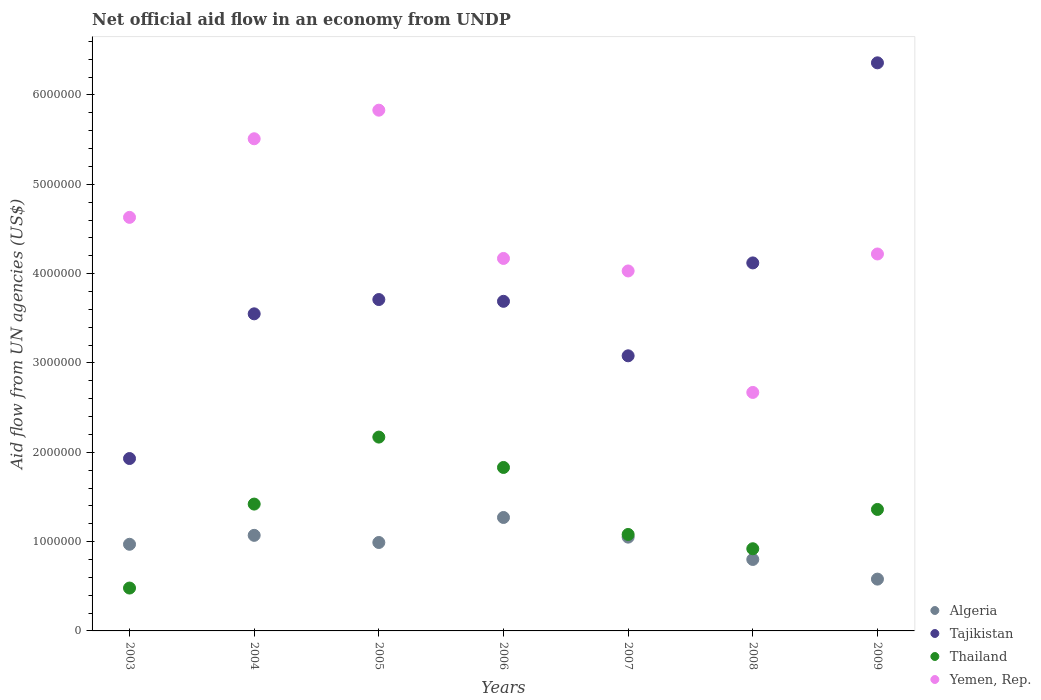What is the net official aid flow in Tajikistan in 2004?
Give a very brief answer. 3.55e+06. Across all years, what is the maximum net official aid flow in Tajikistan?
Provide a short and direct response. 6.36e+06. Across all years, what is the minimum net official aid flow in Thailand?
Make the answer very short. 4.80e+05. What is the total net official aid flow in Algeria in the graph?
Your answer should be very brief. 6.73e+06. What is the difference between the net official aid flow in Tajikistan in 2008 and that in 2009?
Make the answer very short. -2.24e+06. What is the difference between the net official aid flow in Thailand in 2005 and the net official aid flow in Yemen, Rep. in 2007?
Keep it short and to the point. -1.86e+06. What is the average net official aid flow in Thailand per year?
Offer a terse response. 1.32e+06. In the year 2007, what is the difference between the net official aid flow in Tajikistan and net official aid flow in Thailand?
Give a very brief answer. 2.00e+06. In how many years, is the net official aid flow in Yemen, Rep. greater than 5800000 US$?
Your answer should be very brief. 1. What is the ratio of the net official aid flow in Thailand in 2006 to that in 2009?
Provide a short and direct response. 1.35. Is the difference between the net official aid flow in Tajikistan in 2007 and 2008 greater than the difference between the net official aid flow in Thailand in 2007 and 2008?
Your response must be concise. No. What is the difference between the highest and the second highest net official aid flow in Algeria?
Your answer should be compact. 2.00e+05. What is the difference between the highest and the lowest net official aid flow in Thailand?
Offer a very short reply. 1.69e+06. In how many years, is the net official aid flow in Thailand greater than the average net official aid flow in Thailand taken over all years?
Your answer should be very brief. 4. Is the sum of the net official aid flow in Yemen, Rep. in 2003 and 2006 greater than the maximum net official aid flow in Algeria across all years?
Give a very brief answer. Yes. Is it the case that in every year, the sum of the net official aid flow in Tajikistan and net official aid flow in Thailand  is greater than the sum of net official aid flow in Yemen, Rep. and net official aid flow in Algeria?
Ensure brevity in your answer.  Yes. Is it the case that in every year, the sum of the net official aid flow in Thailand and net official aid flow in Yemen, Rep.  is greater than the net official aid flow in Tajikistan?
Give a very brief answer. No. Does the net official aid flow in Algeria monotonically increase over the years?
Your response must be concise. No. Is the net official aid flow in Algeria strictly less than the net official aid flow in Yemen, Rep. over the years?
Your answer should be very brief. Yes. How many years are there in the graph?
Your answer should be compact. 7. Does the graph contain any zero values?
Your response must be concise. No. Does the graph contain grids?
Provide a short and direct response. No. Where does the legend appear in the graph?
Keep it short and to the point. Bottom right. How many legend labels are there?
Your answer should be very brief. 4. What is the title of the graph?
Keep it short and to the point. Net official aid flow in an economy from UNDP. What is the label or title of the X-axis?
Your response must be concise. Years. What is the label or title of the Y-axis?
Give a very brief answer. Aid flow from UN agencies (US$). What is the Aid flow from UN agencies (US$) of Algeria in 2003?
Your response must be concise. 9.70e+05. What is the Aid flow from UN agencies (US$) of Tajikistan in 2003?
Make the answer very short. 1.93e+06. What is the Aid flow from UN agencies (US$) of Yemen, Rep. in 2003?
Your answer should be very brief. 4.63e+06. What is the Aid flow from UN agencies (US$) in Algeria in 2004?
Ensure brevity in your answer.  1.07e+06. What is the Aid flow from UN agencies (US$) in Tajikistan in 2004?
Offer a very short reply. 3.55e+06. What is the Aid flow from UN agencies (US$) in Thailand in 2004?
Your answer should be very brief. 1.42e+06. What is the Aid flow from UN agencies (US$) of Yemen, Rep. in 2004?
Your answer should be very brief. 5.51e+06. What is the Aid flow from UN agencies (US$) of Algeria in 2005?
Keep it short and to the point. 9.90e+05. What is the Aid flow from UN agencies (US$) in Tajikistan in 2005?
Offer a very short reply. 3.71e+06. What is the Aid flow from UN agencies (US$) in Thailand in 2005?
Your answer should be very brief. 2.17e+06. What is the Aid flow from UN agencies (US$) in Yemen, Rep. in 2005?
Your answer should be compact. 5.83e+06. What is the Aid flow from UN agencies (US$) in Algeria in 2006?
Your answer should be compact. 1.27e+06. What is the Aid flow from UN agencies (US$) of Tajikistan in 2006?
Keep it short and to the point. 3.69e+06. What is the Aid flow from UN agencies (US$) of Thailand in 2006?
Ensure brevity in your answer.  1.83e+06. What is the Aid flow from UN agencies (US$) of Yemen, Rep. in 2006?
Offer a very short reply. 4.17e+06. What is the Aid flow from UN agencies (US$) of Algeria in 2007?
Give a very brief answer. 1.05e+06. What is the Aid flow from UN agencies (US$) in Tajikistan in 2007?
Give a very brief answer. 3.08e+06. What is the Aid flow from UN agencies (US$) of Thailand in 2007?
Keep it short and to the point. 1.08e+06. What is the Aid flow from UN agencies (US$) of Yemen, Rep. in 2007?
Provide a succinct answer. 4.03e+06. What is the Aid flow from UN agencies (US$) in Tajikistan in 2008?
Keep it short and to the point. 4.12e+06. What is the Aid flow from UN agencies (US$) of Thailand in 2008?
Make the answer very short. 9.20e+05. What is the Aid flow from UN agencies (US$) in Yemen, Rep. in 2008?
Offer a terse response. 2.67e+06. What is the Aid flow from UN agencies (US$) in Algeria in 2009?
Ensure brevity in your answer.  5.80e+05. What is the Aid flow from UN agencies (US$) of Tajikistan in 2009?
Your answer should be compact. 6.36e+06. What is the Aid flow from UN agencies (US$) in Thailand in 2009?
Offer a very short reply. 1.36e+06. What is the Aid flow from UN agencies (US$) of Yemen, Rep. in 2009?
Ensure brevity in your answer.  4.22e+06. Across all years, what is the maximum Aid flow from UN agencies (US$) in Algeria?
Make the answer very short. 1.27e+06. Across all years, what is the maximum Aid flow from UN agencies (US$) in Tajikistan?
Your answer should be compact. 6.36e+06. Across all years, what is the maximum Aid flow from UN agencies (US$) in Thailand?
Make the answer very short. 2.17e+06. Across all years, what is the maximum Aid flow from UN agencies (US$) in Yemen, Rep.?
Ensure brevity in your answer.  5.83e+06. Across all years, what is the minimum Aid flow from UN agencies (US$) in Algeria?
Ensure brevity in your answer.  5.80e+05. Across all years, what is the minimum Aid flow from UN agencies (US$) of Tajikistan?
Offer a very short reply. 1.93e+06. Across all years, what is the minimum Aid flow from UN agencies (US$) in Yemen, Rep.?
Make the answer very short. 2.67e+06. What is the total Aid flow from UN agencies (US$) in Algeria in the graph?
Offer a very short reply. 6.73e+06. What is the total Aid flow from UN agencies (US$) in Tajikistan in the graph?
Make the answer very short. 2.64e+07. What is the total Aid flow from UN agencies (US$) of Thailand in the graph?
Your response must be concise. 9.26e+06. What is the total Aid flow from UN agencies (US$) of Yemen, Rep. in the graph?
Your response must be concise. 3.11e+07. What is the difference between the Aid flow from UN agencies (US$) of Tajikistan in 2003 and that in 2004?
Provide a succinct answer. -1.62e+06. What is the difference between the Aid flow from UN agencies (US$) in Thailand in 2003 and that in 2004?
Make the answer very short. -9.40e+05. What is the difference between the Aid flow from UN agencies (US$) in Yemen, Rep. in 2003 and that in 2004?
Your answer should be very brief. -8.80e+05. What is the difference between the Aid flow from UN agencies (US$) of Algeria in 2003 and that in 2005?
Keep it short and to the point. -2.00e+04. What is the difference between the Aid flow from UN agencies (US$) of Tajikistan in 2003 and that in 2005?
Keep it short and to the point. -1.78e+06. What is the difference between the Aid flow from UN agencies (US$) of Thailand in 2003 and that in 2005?
Give a very brief answer. -1.69e+06. What is the difference between the Aid flow from UN agencies (US$) in Yemen, Rep. in 2003 and that in 2005?
Provide a succinct answer. -1.20e+06. What is the difference between the Aid flow from UN agencies (US$) in Tajikistan in 2003 and that in 2006?
Your answer should be very brief. -1.76e+06. What is the difference between the Aid flow from UN agencies (US$) in Thailand in 2003 and that in 2006?
Provide a succinct answer. -1.35e+06. What is the difference between the Aid flow from UN agencies (US$) in Yemen, Rep. in 2003 and that in 2006?
Offer a terse response. 4.60e+05. What is the difference between the Aid flow from UN agencies (US$) in Algeria in 2003 and that in 2007?
Offer a very short reply. -8.00e+04. What is the difference between the Aid flow from UN agencies (US$) in Tajikistan in 2003 and that in 2007?
Offer a terse response. -1.15e+06. What is the difference between the Aid flow from UN agencies (US$) of Thailand in 2003 and that in 2007?
Give a very brief answer. -6.00e+05. What is the difference between the Aid flow from UN agencies (US$) in Tajikistan in 2003 and that in 2008?
Offer a very short reply. -2.19e+06. What is the difference between the Aid flow from UN agencies (US$) in Thailand in 2003 and that in 2008?
Give a very brief answer. -4.40e+05. What is the difference between the Aid flow from UN agencies (US$) in Yemen, Rep. in 2003 and that in 2008?
Your response must be concise. 1.96e+06. What is the difference between the Aid flow from UN agencies (US$) in Tajikistan in 2003 and that in 2009?
Ensure brevity in your answer.  -4.43e+06. What is the difference between the Aid flow from UN agencies (US$) of Thailand in 2003 and that in 2009?
Give a very brief answer. -8.80e+05. What is the difference between the Aid flow from UN agencies (US$) of Yemen, Rep. in 2003 and that in 2009?
Give a very brief answer. 4.10e+05. What is the difference between the Aid flow from UN agencies (US$) of Thailand in 2004 and that in 2005?
Provide a short and direct response. -7.50e+05. What is the difference between the Aid flow from UN agencies (US$) of Yemen, Rep. in 2004 and that in 2005?
Your response must be concise. -3.20e+05. What is the difference between the Aid flow from UN agencies (US$) of Algeria in 2004 and that in 2006?
Keep it short and to the point. -2.00e+05. What is the difference between the Aid flow from UN agencies (US$) of Thailand in 2004 and that in 2006?
Keep it short and to the point. -4.10e+05. What is the difference between the Aid flow from UN agencies (US$) in Yemen, Rep. in 2004 and that in 2006?
Your answer should be very brief. 1.34e+06. What is the difference between the Aid flow from UN agencies (US$) of Algeria in 2004 and that in 2007?
Keep it short and to the point. 2.00e+04. What is the difference between the Aid flow from UN agencies (US$) of Tajikistan in 2004 and that in 2007?
Your answer should be very brief. 4.70e+05. What is the difference between the Aid flow from UN agencies (US$) in Thailand in 2004 and that in 2007?
Offer a terse response. 3.40e+05. What is the difference between the Aid flow from UN agencies (US$) in Yemen, Rep. in 2004 and that in 2007?
Your answer should be compact. 1.48e+06. What is the difference between the Aid flow from UN agencies (US$) in Tajikistan in 2004 and that in 2008?
Your answer should be very brief. -5.70e+05. What is the difference between the Aid flow from UN agencies (US$) in Yemen, Rep. in 2004 and that in 2008?
Offer a very short reply. 2.84e+06. What is the difference between the Aid flow from UN agencies (US$) of Tajikistan in 2004 and that in 2009?
Your response must be concise. -2.81e+06. What is the difference between the Aid flow from UN agencies (US$) of Yemen, Rep. in 2004 and that in 2009?
Your response must be concise. 1.29e+06. What is the difference between the Aid flow from UN agencies (US$) of Algeria in 2005 and that in 2006?
Your answer should be very brief. -2.80e+05. What is the difference between the Aid flow from UN agencies (US$) in Thailand in 2005 and that in 2006?
Offer a very short reply. 3.40e+05. What is the difference between the Aid flow from UN agencies (US$) in Yemen, Rep. in 2005 and that in 2006?
Give a very brief answer. 1.66e+06. What is the difference between the Aid flow from UN agencies (US$) of Tajikistan in 2005 and that in 2007?
Make the answer very short. 6.30e+05. What is the difference between the Aid flow from UN agencies (US$) in Thailand in 2005 and that in 2007?
Your answer should be very brief. 1.09e+06. What is the difference between the Aid flow from UN agencies (US$) of Yemen, Rep. in 2005 and that in 2007?
Offer a very short reply. 1.80e+06. What is the difference between the Aid flow from UN agencies (US$) in Algeria in 2005 and that in 2008?
Offer a very short reply. 1.90e+05. What is the difference between the Aid flow from UN agencies (US$) in Tajikistan in 2005 and that in 2008?
Offer a very short reply. -4.10e+05. What is the difference between the Aid flow from UN agencies (US$) in Thailand in 2005 and that in 2008?
Give a very brief answer. 1.25e+06. What is the difference between the Aid flow from UN agencies (US$) in Yemen, Rep. in 2005 and that in 2008?
Offer a very short reply. 3.16e+06. What is the difference between the Aid flow from UN agencies (US$) of Algeria in 2005 and that in 2009?
Ensure brevity in your answer.  4.10e+05. What is the difference between the Aid flow from UN agencies (US$) in Tajikistan in 2005 and that in 2009?
Keep it short and to the point. -2.65e+06. What is the difference between the Aid flow from UN agencies (US$) in Thailand in 2005 and that in 2009?
Provide a succinct answer. 8.10e+05. What is the difference between the Aid flow from UN agencies (US$) in Yemen, Rep. in 2005 and that in 2009?
Your answer should be very brief. 1.61e+06. What is the difference between the Aid flow from UN agencies (US$) in Tajikistan in 2006 and that in 2007?
Give a very brief answer. 6.10e+05. What is the difference between the Aid flow from UN agencies (US$) of Thailand in 2006 and that in 2007?
Provide a succinct answer. 7.50e+05. What is the difference between the Aid flow from UN agencies (US$) in Yemen, Rep. in 2006 and that in 2007?
Provide a succinct answer. 1.40e+05. What is the difference between the Aid flow from UN agencies (US$) in Algeria in 2006 and that in 2008?
Offer a very short reply. 4.70e+05. What is the difference between the Aid flow from UN agencies (US$) in Tajikistan in 2006 and that in 2008?
Make the answer very short. -4.30e+05. What is the difference between the Aid flow from UN agencies (US$) of Thailand in 2006 and that in 2008?
Give a very brief answer. 9.10e+05. What is the difference between the Aid flow from UN agencies (US$) of Yemen, Rep. in 2006 and that in 2008?
Your response must be concise. 1.50e+06. What is the difference between the Aid flow from UN agencies (US$) in Algeria in 2006 and that in 2009?
Your response must be concise. 6.90e+05. What is the difference between the Aid flow from UN agencies (US$) in Tajikistan in 2006 and that in 2009?
Your answer should be compact. -2.67e+06. What is the difference between the Aid flow from UN agencies (US$) in Tajikistan in 2007 and that in 2008?
Keep it short and to the point. -1.04e+06. What is the difference between the Aid flow from UN agencies (US$) in Yemen, Rep. in 2007 and that in 2008?
Provide a succinct answer. 1.36e+06. What is the difference between the Aid flow from UN agencies (US$) of Tajikistan in 2007 and that in 2009?
Offer a very short reply. -3.28e+06. What is the difference between the Aid flow from UN agencies (US$) of Thailand in 2007 and that in 2009?
Your response must be concise. -2.80e+05. What is the difference between the Aid flow from UN agencies (US$) in Algeria in 2008 and that in 2009?
Ensure brevity in your answer.  2.20e+05. What is the difference between the Aid flow from UN agencies (US$) in Tajikistan in 2008 and that in 2009?
Provide a short and direct response. -2.24e+06. What is the difference between the Aid flow from UN agencies (US$) in Thailand in 2008 and that in 2009?
Provide a succinct answer. -4.40e+05. What is the difference between the Aid flow from UN agencies (US$) in Yemen, Rep. in 2008 and that in 2009?
Your answer should be very brief. -1.55e+06. What is the difference between the Aid flow from UN agencies (US$) of Algeria in 2003 and the Aid flow from UN agencies (US$) of Tajikistan in 2004?
Offer a terse response. -2.58e+06. What is the difference between the Aid flow from UN agencies (US$) in Algeria in 2003 and the Aid flow from UN agencies (US$) in Thailand in 2004?
Offer a very short reply. -4.50e+05. What is the difference between the Aid flow from UN agencies (US$) of Algeria in 2003 and the Aid flow from UN agencies (US$) of Yemen, Rep. in 2004?
Give a very brief answer. -4.54e+06. What is the difference between the Aid flow from UN agencies (US$) of Tajikistan in 2003 and the Aid flow from UN agencies (US$) of Thailand in 2004?
Your answer should be compact. 5.10e+05. What is the difference between the Aid flow from UN agencies (US$) in Tajikistan in 2003 and the Aid flow from UN agencies (US$) in Yemen, Rep. in 2004?
Keep it short and to the point. -3.58e+06. What is the difference between the Aid flow from UN agencies (US$) in Thailand in 2003 and the Aid flow from UN agencies (US$) in Yemen, Rep. in 2004?
Your answer should be very brief. -5.03e+06. What is the difference between the Aid flow from UN agencies (US$) of Algeria in 2003 and the Aid flow from UN agencies (US$) of Tajikistan in 2005?
Provide a short and direct response. -2.74e+06. What is the difference between the Aid flow from UN agencies (US$) of Algeria in 2003 and the Aid flow from UN agencies (US$) of Thailand in 2005?
Provide a succinct answer. -1.20e+06. What is the difference between the Aid flow from UN agencies (US$) of Algeria in 2003 and the Aid flow from UN agencies (US$) of Yemen, Rep. in 2005?
Offer a very short reply. -4.86e+06. What is the difference between the Aid flow from UN agencies (US$) of Tajikistan in 2003 and the Aid flow from UN agencies (US$) of Thailand in 2005?
Your answer should be compact. -2.40e+05. What is the difference between the Aid flow from UN agencies (US$) in Tajikistan in 2003 and the Aid flow from UN agencies (US$) in Yemen, Rep. in 2005?
Provide a succinct answer. -3.90e+06. What is the difference between the Aid flow from UN agencies (US$) in Thailand in 2003 and the Aid flow from UN agencies (US$) in Yemen, Rep. in 2005?
Your answer should be very brief. -5.35e+06. What is the difference between the Aid flow from UN agencies (US$) of Algeria in 2003 and the Aid flow from UN agencies (US$) of Tajikistan in 2006?
Offer a very short reply. -2.72e+06. What is the difference between the Aid flow from UN agencies (US$) of Algeria in 2003 and the Aid flow from UN agencies (US$) of Thailand in 2006?
Ensure brevity in your answer.  -8.60e+05. What is the difference between the Aid flow from UN agencies (US$) of Algeria in 2003 and the Aid flow from UN agencies (US$) of Yemen, Rep. in 2006?
Make the answer very short. -3.20e+06. What is the difference between the Aid flow from UN agencies (US$) in Tajikistan in 2003 and the Aid flow from UN agencies (US$) in Yemen, Rep. in 2006?
Your answer should be compact. -2.24e+06. What is the difference between the Aid flow from UN agencies (US$) of Thailand in 2003 and the Aid flow from UN agencies (US$) of Yemen, Rep. in 2006?
Make the answer very short. -3.69e+06. What is the difference between the Aid flow from UN agencies (US$) of Algeria in 2003 and the Aid flow from UN agencies (US$) of Tajikistan in 2007?
Provide a short and direct response. -2.11e+06. What is the difference between the Aid flow from UN agencies (US$) of Algeria in 2003 and the Aid flow from UN agencies (US$) of Yemen, Rep. in 2007?
Offer a terse response. -3.06e+06. What is the difference between the Aid flow from UN agencies (US$) in Tajikistan in 2003 and the Aid flow from UN agencies (US$) in Thailand in 2007?
Your answer should be compact. 8.50e+05. What is the difference between the Aid flow from UN agencies (US$) in Tajikistan in 2003 and the Aid flow from UN agencies (US$) in Yemen, Rep. in 2007?
Your answer should be compact. -2.10e+06. What is the difference between the Aid flow from UN agencies (US$) in Thailand in 2003 and the Aid flow from UN agencies (US$) in Yemen, Rep. in 2007?
Offer a very short reply. -3.55e+06. What is the difference between the Aid flow from UN agencies (US$) of Algeria in 2003 and the Aid flow from UN agencies (US$) of Tajikistan in 2008?
Your answer should be very brief. -3.15e+06. What is the difference between the Aid flow from UN agencies (US$) of Algeria in 2003 and the Aid flow from UN agencies (US$) of Thailand in 2008?
Provide a succinct answer. 5.00e+04. What is the difference between the Aid flow from UN agencies (US$) of Algeria in 2003 and the Aid flow from UN agencies (US$) of Yemen, Rep. in 2008?
Provide a succinct answer. -1.70e+06. What is the difference between the Aid flow from UN agencies (US$) in Tajikistan in 2003 and the Aid flow from UN agencies (US$) in Thailand in 2008?
Your response must be concise. 1.01e+06. What is the difference between the Aid flow from UN agencies (US$) in Tajikistan in 2003 and the Aid flow from UN agencies (US$) in Yemen, Rep. in 2008?
Offer a very short reply. -7.40e+05. What is the difference between the Aid flow from UN agencies (US$) in Thailand in 2003 and the Aid flow from UN agencies (US$) in Yemen, Rep. in 2008?
Offer a terse response. -2.19e+06. What is the difference between the Aid flow from UN agencies (US$) in Algeria in 2003 and the Aid flow from UN agencies (US$) in Tajikistan in 2009?
Keep it short and to the point. -5.39e+06. What is the difference between the Aid flow from UN agencies (US$) of Algeria in 2003 and the Aid flow from UN agencies (US$) of Thailand in 2009?
Ensure brevity in your answer.  -3.90e+05. What is the difference between the Aid flow from UN agencies (US$) of Algeria in 2003 and the Aid flow from UN agencies (US$) of Yemen, Rep. in 2009?
Provide a succinct answer. -3.25e+06. What is the difference between the Aid flow from UN agencies (US$) in Tajikistan in 2003 and the Aid flow from UN agencies (US$) in Thailand in 2009?
Ensure brevity in your answer.  5.70e+05. What is the difference between the Aid flow from UN agencies (US$) of Tajikistan in 2003 and the Aid flow from UN agencies (US$) of Yemen, Rep. in 2009?
Offer a terse response. -2.29e+06. What is the difference between the Aid flow from UN agencies (US$) of Thailand in 2003 and the Aid flow from UN agencies (US$) of Yemen, Rep. in 2009?
Give a very brief answer. -3.74e+06. What is the difference between the Aid flow from UN agencies (US$) of Algeria in 2004 and the Aid flow from UN agencies (US$) of Tajikistan in 2005?
Your answer should be compact. -2.64e+06. What is the difference between the Aid flow from UN agencies (US$) in Algeria in 2004 and the Aid flow from UN agencies (US$) in Thailand in 2005?
Make the answer very short. -1.10e+06. What is the difference between the Aid flow from UN agencies (US$) in Algeria in 2004 and the Aid flow from UN agencies (US$) in Yemen, Rep. in 2005?
Keep it short and to the point. -4.76e+06. What is the difference between the Aid flow from UN agencies (US$) of Tajikistan in 2004 and the Aid flow from UN agencies (US$) of Thailand in 2005?
Your answer should be very brief. 1.38e+06. What is the difference between the Aid flow from UN agencies (US$) of Tajikistan in 2004 and the Aid flow from UN agencies (US$) of Yemen, Rep. in 2005?
Offer a very short reply. -2.28e+06. What is the difference between the Aid flow from UN agencies (US$) of Thailand in 2004 and the Aid flow from UN agencies (US$) of Yemen, Rep. in 2005?
Your answer should be compact. -4.41e+06. What is the difference between the Aid flow from UN agencies (US$) of Algeria in 2004 and the Aid flow from UN agencies (US$) of Tajikistan in 2006?
Your answer should be compact. -2.62e+06. What is the difference between the Aid flow from UN agencies (US$) in Algeria in 2004 and the Aid flow from UN agencies (US$) in Thailand in 2006?
Provide a succinct answer. -7.60e+05. What is the difference between the Aid flow from UN agencies (US$) of Algeria in 2004 and the Aid flow from UN agencies (US$) of Yemen, Rep. in 2006?
Give a very brief answer. -3.10e+06. What is the difference between the Aid flow from UN agencies (US$) in Tajikistan in 2004 and the Aid flow from UN agencies (US$) in Thailand in 2006?
Your answer should be very brief. 1.72e+06. What is the difference between the Aid flow from UN agencies (US$) of Tajikistan in 2004 and the Aid flow from UN agencies (US$) of Yemen, Rep. in 2006?
Offer a very short reply. -6.20e+05. What is the difference between the Aid flow from UN agencies (US$) of Thailand in 2004 and the Aid flow from UN agencies (US$) of Yemen, Rep. in 2006?
Your answer should be very brief. -2.75e+06. What is the difference between the Aid flow from UN agencies (US$) of Algeria in 2004 and the Aid flow from UN agencies (US$) of Tajikistan in 2007?
Offer a terse response. -2.01e+06. What is the difference between the Aid flow from UN agencies (US$) in Algeria in 2004 and the Aid flow from UN agencies (US$) in Yemen, Rep. in 2007?
Offer a very short reply. -2.96e+06. What is the difference between the Aid flow from UN agencies (US$) of Tajikistan in 2004 and the Aid flow from UN agencies (US$) of Thailand in 2007?
Ensure brevity in your answer.  2.47e+06. What is the difference between the Aid flow from UN agencies (US$) in Tajikistan in 2004 and the Aid flow from UN agencies (US$) in Yemen, Rep. in 2007?
Offer a terse response. -4.80e+05. What is the difference between the Aid flow from UN agencies (US$) in Thailand in 2004 and the Aid flow from UN agencies (US$) in Yemen, Rep. in 2007?
Ensure brevity in your answer.  -2.61e+06. What is the difference between the Aid flow from UN agencies (US$) of Algeria in 2004 and the Aid flow from UN agencies (US$) of Tajikistan in 2008?
Make the answer very short. -3.05e+06. What is the difference between the Aid flow from UN agencies (US$) in Algeria in 2004 and the Aid flow from UN agencies (US$) in Thailand in 2008?
Keep it short and to the point. 1.50e+05. What is the difference between the Aid flow from UN agencies (US$) in Algeria in 2004 and the Aid flow from UN agencies (US$) in Yemen, Rep. in 2008?
Your response must be concise. -1.60e+06. What is the difference between the Aid flow from UN agencies (US$) in Tajikistan in 2004 and the Aid flow from UN agencies (US$) in Thailand in 2008?
Make the answer very short. 2.63e+06. What is the difference between the Aid flow from UN agencies (US$) of Tajikistan in 2004 and the Aid flow from UN agencies (US$) of Yemen, Rep. in 2008?
Give a very brief answer. 8.80e+05. What is the difference between the Aid flow from UN agencies (US$) in Thailand in 2004 and the Aid flow from UN agencies (US$) in Yemen, Rep. in 2008?
Offer a very short reply. -1.25e+06. What is the difference between the Aid flow from UN agencies (US$) of Algeria in 2004 and the Aid flow from UN agencies (US$) of Tajikistan in 2009?
Keep it short and to the point. -5.29e+06. What is the difference between the Aid flow from UN agencies (US$) in Algeria in 2004 and the Aid flow from UN agencies (US$) in Yemen, Rep. in 2009?
Ensure brevity in your answer.  -3.15e+06. What is the difference between the Aid flow from UN agencies (US$) of Tajikistan in 2004 and the Aid flow from UN agencies (US$) of Thailand in 2009?
Offer a terse response. 2.19e+06. What is the difference between the Aid flow from UN agencies (US$) in Tajikistan in 2004 and the Aid flow from UN agencies (US$) in Yemen, Rep. in 2009?
Give a very brief answer. -6.70e+05. What is the difference between the Aid flow from UN agencies (US$) in Thailand in 2004 and the Aid flow from UN agencies (US$) in Yemen, Rep. in 2009?
Offer a terse response. -2.80e+06. What is the difference between the Aid flow from UN agencies (US$) of Algeria in 2005 and the Aid flow from UN agencies (US$) of Tajikistan in 2006?
Offer a very short reply. -2.70e+06. What is the difference between the Aid flow from UN agencies (US$) in Algeria in 2005 and the Aid flow from UN agencies (US$) in Thailand in 2006?
Ensure brevity in your answer.  -8.40e+05. What is the difference between the Aid flow from UN agencies (US$) in Algeria in 2005 and the Aid flow from UN agencies (US$) in Yemen, Rep. in 2006?
Your answer should be compact. -3.18e+06. What is the difference between the Aid flow from UN agencies (US$) in Tajikistan in 2005 and the Aid flow from UN agencies (US$) in Thailand in 2006?
Ensure brevity in your answer.  1.88e+06. What is the difference between the Aid flow from UN agencies (US$) in Tajikistan in 2005 and the Aid flow from UN agencies (US$) in Yemen, Rep. in 2006?
Your answer should be compact. -4.60e+05. What is the difference between the Aid flow from UN agencies (US$) of Algeria in 2005 and the Aid flow from UN agencies (US$) of Tajikistan in 2007?
Your answer should be very brief. -2.09e+06. What is the difference between the Aid flow from UN agencies (US$) of Algeria in 2005 and the Aid flow from UN agencies (US$) of Thailand in 2007?
Offer a very short reply. -9.00e+04. What is the difference between the Aid flow from UN agencies (US$) of Algeria in 2005 and the Aid flow from UN agencies (US$) of Yemen, Rep. in 2007?
Offer a very short reply. -3.04e+06. What is the difference between the Aid flow from UN agencies (US$) in Tajikistan in 2005 and the Aid flow from UN agencies (US$) in Thailand in 2007?
Make the answer very short. 2.63e+06. What is the difference between the Aid flow from UN agencies (US$) of Tajikistan in 2005 and the Aid flow from UN agencies (US$) of Yemen, Rep. in 2007?
Offer a terse response. -3.20e+05. What is the difference between the Aid flow from UN agencies (US$) of Thailand in 2005 and the Aid flow from UN agencies (US$) of Yemen, Rep. in 2007?
Your answer should be compact. -1.86e+06. What is the difference between the Aid flow from UN agencies (US$) in Algeria in 2005 and the Aid flow from UN agencies (US$) in Tajikistan in 2008?
Provide a succinct answer. -3.13e+06. What is the difference between the Aid flow from UN agencies (US$) of Algeria in 2005 and the Aid flow from UN agencies (US$) of Thailand in 2008?
Offer a very short reply. 7.00e+04. What is the difference between the Aid flow from UN agencies (US$) in Algeria in 2005 and the Aid flow from UN agencies (US$) in Yemen, Rep. in 2008?
Ensure brevity in your answer.  -1.68e+06. What is the difference between the Aid flow from UN agencies (US$) in Tajikistan in 2005 and the Aid flow from UN agencies (US$) in Thailand in 2008?
Give a very brief answer. 2.79e+06. What is the difference between the Aid flow from UN agencies (US$) of Tajikistan in 2005 and the Aid flow from UN agencies (US$) of Yemen, Rep. in 2008?
Your answer should be compact. 1.04e+06. What is the difference between the Aid flow from UN agencies (US$) in Thailand in 2005 and the Aid flow from UN agencies (US$) in Yemen, Rep. in 2008?
Keep it short and to the point. -5.00e+05. What is the difference between the Aid flow from UN agencies (US$) in Algeria in 2005 and the Aid flow from UN agencies (US$) in Tajikistan in 2009?
Your answer should be very brief. -5.37e+06. What is the difference between the Aid flow from UN agencies (US$) of Algeria in 2005 and the Aid flow from UN agencies (US$) of Thailand in 2009?
Ensure brevity in your answer.  -3.70e+05. What is the difference between the Aid flow from UN agencies (US$) of Algeria in 2005 and the Aid flow from UN agencies (US$) of Yemen, Rep. in 2009?
Keep it short and to the point. -3.23e+06. What is the difference between the Aid flow from UN agencies (US$) in Tajikistan in 2005 and the Aid flow from UN agencies (US$) in Thailand in 2009?
Provide a short and direct response. 2.35e+06. What is the difference between the Aid flow from UN agencies (US$) in Tajikistan in 2005 and the Aid flow from UN agencies (US$) in Yemen, Rep. in 2009?
Offer a very short reply. -5.10e+05. What is the difference between the Aid flow from UN agencies (US$) in Thailand in 2005 and the Aid flow from UN agencies (US$) in Yemen, Rep. in 2009?
Offer a very short reply. -2.05e+06. What is the difference between the Aid flow from UN agencies (US$) of Algeria in 2006 and the Aid flow from UN agencies (US$) of Tajikistan in 2007?
Provide a short and direct response. -1.81e+06. What is the difference between the Aid flow from UN agencies (US$) in Algeria in 2006 and the Aid flow from UN agencies (US$) in Thailand in 2007?
Ensure brevity in your answer.  1.90e+05. What is the difference between the Aid flow from UN agencies (US$) of Algeria in 2006 and the Aid flow from UN agencies (US$) of Yemen, Rep. in 2007?
Provide a succinct answer. -2.76e+06. What is the difference between the Aid flow from UN agencies (US$) of Tajikistan in 2006 and the Aid flow from UN agencies (US$) of Thailand in 2007?
Your answer should be very brief. 2.61e+06. What is the difference between the Aid flow from UN agencies (US$) of Tajikistan in 2006 and the Aid flow from UN agencies (US$) of Yemen, Rep. in 2007?
Your response must be concise. -3.40e+05. What is the difference between the Aid flow from UN agencies (US$) of Thailand in 2006 and the Aid flow from UN agencies (US$) of Yemen, Rep. in 2007?
Provide a succinct answer. -2.20e+06. What is the difference between the Aid flow from UN agencies (US$) in Algeria in 2006 and the Aid flow from UN agencies (US$) in Tajikistan in 2008?
Keep it short and to the point. -2.85e+06. What is the difference between the Aid flow from UN agencies (US$) in Algeria in 2006 and the Aid flow from UN agencies (US$) in Thailand in 2008?
Your response must be concise. 3.50e+05. What is the difference between the Aid flow from UN agencies (US$) in Algeria in 2006 and the Aid flow from UN agencies (US$) in Yemen, Rep. in 2008?
Ensure brevity in your answer.  -1.40e+06. What is the difference between the Aid flow from UN agencies (US$) of Tajikistan in 2006 and the Aid flow from UN agencies (US$) of Thailand in 2008?
Make the answer very short. 2.77e+06. What is the difference between the Aid flow from UN agencies (US$) of Tajikistan in 2006 and the Aid flow from UN agencies (US$) of Yemen, Rep. in 2008?
Provide a short and direct response. 1.02e+06. What is the difference between the Aid flow from UN agencies (US$) of Thailand in 2006 and the Aid flow from UN agencies (US$) of Yemen, Rep. in 2008?
Provide a succinct answer. -8.40e+05. What is the difference between the Aid flow from UN agencies (US$) of Algeria in 2006 and the Aid flow from UN agencies (US$) of Tajikistan in 2009?
Your answer should be compact. -5.09e+06. What is the difference between the Aid flow from UN agencies (US$) of Algeria in 2006 and the Aid flow from UN agencies (US$) of Thailand in 2009?
Offer a very short reply. -9.00e+04. What is the difference between the Aid flow from UN agencies (US$) in Algeria in 2006 and the Aid flow from UN agencies (US$) in Yemen, Rep. in 2009?
Keep it short and to the point. -2.95e+06. What is the difference between the Aid flow from UN agencies (US$) in Tajikistan in 2006 and the Aid flow from UN agencies (US$) in Thailand in 2009?
Provide a succinct answer. 2.33e+06. What is the difference between the Aid flow from UN agencies (US$) of Tajikistan in 2006 and the Aid flow from UN agencies (US$) of Yemen, Rep. in 2009?
Your answer should be compact. -5.30e+05. What is the difference between the Aid flow from UN agencies (US$) of Thailand in 2006 and the Aid flow from UN agencies (US$) of Yemen, Rep. in 2009?
Offer a very short reply. -2.39e+06. What is the difference between the Aid flow from UN agencies (US$) of Algeria in 2007 and the Aid flow from UN agencies (US$) of Tajikistan in 2008?
Your answer should be very brief. -3.07e+06. What is the difference between the Aid flow from UN agencies (US$) in Algeria in 2007 and the Aid flow from UN agencies (US$) in Thailand in 2008?
Provide a succinct answer. 1.30e+05. What is the difference between the Aid flow from UN agencies (US$) of Algeria in 2007 and the Aid flow from UN agencies (US$) of Yemen, Rep. in 2008?
Make the answer very short. -1.62e+06. What is the difference between the Aid flow from UN agencies (US$) in Tajikistan in 2007 and the Aid flow from UN agencies (US$) in Thailand in 2008?
Ensure brevity in your answer.  2.16e+06. What is the difference between the Aid flow from UN agencies (US$) in Tajikistan in 2007 and the Aid flow from UN agencies (US$) in Yemen, Rep. in 2008?
Your response must be concise. 4.10e+05. What is the difference between the Aid flow from UN agencies (US$) of Thailand in 2007 and the Aid flow from UN agencies (US$) of Yemen, Rep. in 2008?
Make the answer very short. -1.59e+06. What is the difference between the Aid flow from UN agencies (US$) of Algeria in 2007 and the Aid flow from UN agencies (US$) of Tajikistan in 2009?
Ensure brevity in your answer.  -5.31e+06. What is the difference between the Aid flow from UN agencies (US$) in Algeria in 2007 and the Aid flow from UN agencies (US$) in Thailand in 2009?
Provide a succinct answer. -3.10e+05. What is the difference between the Aid flow from UN agencies (US$) in Algeria in 2007 and the Aid flow from UN agencies (US$) in Yemen, Rep. in 2009?
Your answer should be very brief. -3.17e+06. What is the difference between the Aid flow from UN agencies (US$) of Tajikistan in 2007 and the Aid flow from UN agencies (US$) of Thailand in 2009?
Make the answer very short. 1.72e+06. What is the difference between the Aid flow from UN agencies (US$) in Tajikistan in 2007 and the Aid flow from UN agencies (US$) in Yemen, Rep. in 2009?
Your answer should be very brief. -1.14e+06. What is the difference between the Aid flow from UN agencies (US$) of Thailand in 2007 and the Aid flow from UN agencies (US$) of Yemen, Rep. in 2009?
Provide a short and direct response. -3.14e+06. What is the difference between the Aid flow from UN agencies (US$) in Algeria in 2008 and the Aid flow from UN agencies (US$) in Tajikistan in 2009?
Your answer should be very brief. -5.56e+06. What is the difference between the Aid flow from UN agencies (US$) in Algeria in 2008 and the Aid flow from UN agencies (US$) in Thailand in 2009?
Keep it short and to the point. -5.60e+05. What is the difference between the Aid flow from UN agencies (US$) in Algeria in 2008 and the Aid flow from UN agencies (US$) in Yemen, Rep. in 2009?
Your answer should be very brief. -3.42e+06. What is the difference between the Aid flow from UN agencies (US$) of Tajikistan in 2008 and the Aid flow from UN agencies (US$) of Thailand in 2009?
Offer a terse response. 2.76e+06. What is the difference between the Aid flow from UN agencies (US$) of Thailand in 2008 and the Aid flow from UN agencies (US$) of Yemen, Rep. in 2009?
Provide a short and direct response. -3.30e+06. What is the average Aid flow from UN agencies (US$) in Algeria per year?
Your answer should be compact. 9.61e+05. What is the average Aid flow from UN agencies (US$) of Tajikistan per year?
Offer a very short reply. 3.78e+06. What is the average Aid flow from UN agencies (US$) in Thailand per year?
Your answer should be very brief. 1.32e+06. What is the average Aid flow from UN agencies (US$) in Yemen, Rep. per year?
Your answer should be very brief. 4.44e+06. In the year 2003, what is the difference between the Aid flow from UN agencies (US$) in Algeria and Aid flow from UN agencies (US$) in Tajikistan?
Keep it short and to the point. -9.60e+05. In the year 2003, what is the difference between the Aid flow from UN agencies (US$) of Algeria and Aid flow from UN agencies (US$) of Yemen, Rep.?
Offer a terse response. -3.66e+06. In the year 2003, what is the difference between the Aid flow from UN agencies (US$) in Tajikistan and Aid flow from UN agencies (US$) in Thailand?
Provide a succinct answer. 1.45e+06. In the year 2003, what is the difference between the Aid flow from UN agencies (US$) in Tajikistan and Aid flow from UN agencies (US$) in Yemen, Rep.?
Your response must be concise. -2.70e+06. In the year 2003, what is the difference between the Aid flow from UN agencies (US$) in Thailand and Aid flow from UN agencies (US$) in Yemen, Rep.?
Make the answer very short. -4.15e+06. In the year 2004, what is the difference between the Aid flow from UN agencies (US$) of Algeria and Aid flow from UN agencies (US$) of Tajikistan?
Provide a short and direct response. -2.48e+06. In the year 2004, what is the difference between the Aid flow from UN agencies (US$) of Algeria and Aid flow from UN agencies (US$) of Thailand?
Provide a short and direct response. -3.50e+05. In the year 2004, what is the difference between the Aid flow from UN agencies (US$) in Algeria and Aid flow from UN agencies (US$) in Yemen, Rep.?
Provide a succinct answer. -4.44e+06. In the year 2004, what is the difference between the Aid flow from UN agencies (US$) in Tajikistan and Aid flow from UN agencies (US$) in Thailand?
Your answer should be very brief. 2.13e+06. In the year 2004, what is the difference between the Aid flow from UN agencies (US$) in Tajikistan and Aid flow from UN agencies (US$) in Yemen, Rep.?
Provide a short and direct response. -1.96e+06. In the year 2004, what is the difference between the Aid flow from UN agencies (US$) of Thailand and Aid flow from UN agencies (US$) of Yemen, Rep.?
Provide a succinct answer. -4.09e+06. In the year 2005, what is the difference between the Aid flow from UN agencies (US$) in Algeria and Aid flow from UN agencies (US$) in Tajikistan?
Your answer should be very brief. -2.72e+06. In the year 2005, what is the difference between the Aid flow from UN agencies (US$) of Algeria and Aid flow from UN agencies (US$) of Thailand?
Provide a short and direct response. -1.18e+06. In the year 2005, what is the difference between the Aid flow from UN agencies (US$) of Algeria and Aid flow from UN agencies (US$) of Yemen, Rep.?
Your response must be concise. -4.84e+06. In the year 2005, what is the difference between the Aid flow from UN agencies (US$) of Tajikistan and Aid flow from UN agencies (US$) of Thailand?
Provide a short and direct response. 1.54e+06. In the year 2005, what is the difference between the Aid flow from UN agencies (US$) in Tajikistan and Aid flow from UN agencies (US$) in Yemen, Rep.?
Your answer should be very brief. -2.12e+06. In the year 2005, what is the difference between the Aid flow from UN agencies (US$) of Thailand and Aid flow from UN agencies (US$) of Yemen, Rep.?
Ensure brevity in your answer.  -3.66e+06. In the year 2006, what is the difference between the Aid flow from UN agencies (US$) in Algeria and Aid flow from UN agencies (US$) in Tajikistan?
Keep it short and to the point. -2.42e+06. In the year 2006, what is the difference between the Aid flow from UN agencies (US$) in Algeria and Aid flow from UN agencies (US$) in Thailand?
Your answer should be compact. -5.60e+05. In the year 2006, what is the difference between the Aid flow from UN agencies (US$) in Algeria and Aid flow from UN agencies (US$) in Yemen, Rep.?
Ensure brevity in your answer.  -2.90e+06. In the year 2006, what is the difference between the Aid flow from UN agencies (US$) of Tajikistan and Aid flow from UN agencies (US$) of Thailand?
Your answer should be compact. 1.86e+06. In the year 2006, what is the difference between the Aid flow from UN agencies (US$) of Tajikistan and Aid flow from UN agencies (US$) of Yemen, Rep.?
Offer a very short reply. -4.80e+05. In the year 2006, what is the difference between the Aid flow from UN agencies (US$) in Thailand and Aid flow from UN agencies (US$) in Yemen, Rep.?
Ensure brevity in your answer.  -2.34e+06. In the year 2007, what is the difference between the Aid flow from UN agencies (US$) of Algeria and Aid flow from UN agencies (US$) of Tajikistan?
Your answer should be very brief. -2.03e+06. In the year 2007, what is the difference between the Aid flow from UN agencies (US$) of Algeria and Aid flow from UN agencies (US$) of Thailand?
Offer a terse response. -3.00e+04. In the year 2007, what is the difference between the Aid flow from UN agencies (US$) in Algeria and Aid flow from UN agencies (US$) in Yemen, Rep.?
Make the answer very short. -2.98e+06. In the year 2007, what is the difference between the Aid flow from UN agencies (US$) in Tajikistan and Aid flow from UN agencies (US$) in Thailand?
Ensure brevity in your answer.  2.00e+06. In the year 2007, what is the difference between the Aid flow from UN agencies (US$) of Tajikistan and Aid flow from UN agencies (US$) of Yemen, Rep.?
Provide a succinct answer. -9.50e+05. In the year 2007, what is the difference between the Aid flow from UN agencies (US$) of Thailand and Aid flow from UN agencies (US$) of Yemen, Rep.?
Give a very brief answer. -2.95e+06. In the year 2008, what is the difference between the Aid flow from UN agencies (US$) of Algeria and Aid flow from UN agencies (US$) of Tajikistan?
Your answer should be compact. -3.32e+06. In the year 2008, what is the difference between the Aid flow from UN agencies (US$) of Algeria and Aid flow from UN agencies (US$) of Yemen, Rep.?
Provide a short and direct response. -1.87e+06. In the year 2008, what is the difference between the Aid flow from UN agencies (US$) of Tajikistan and Aid flow from UN agencies (US$) of Thailand?
Your answer should be very brief. 3.20e+06. In the year 2008, what is the difference between the Aid flow from UN agencies (US$) of Tajikistan and Aid flow from UN agencies (US$) of Yemen, Rep.?
Ensure brevity in your answer.  1.45e+06. In the year 2008, what is the difference between the Aid flow from UN agencies (US$) in Thailand and Aid flow from UN agencies (US$) in Yemen, Rep.?
Provide a succinct answer. -1.75e+06. In the year 2009, what is the difference between the Aid flow from UN agencies (US$) in Algeria and Aid flow from UN agencies (US$) in Tajikistan?
Make the answer very short. -5.78e+06. In the year 2009, what is the difference between the Aid flow from UN agencies (US$) of Algeria and Aid flow from UN agencies (US$) of Thailand?
Your answer should be very brief. -7.80e+05. In the year 2009, what is the difference between the Aid flow from UN agencies (US$) in Algeria and Aid flow from UN agencies (US$) in Yemen, Rep.?
Keep it short and to the point. -3.64e+06. In the year 2009, what is the difference between the Aid flow from UN agencies (US$) in Tajikistan and Aid flow from UN agencies (US$) in Yemen, Rep.?
Offer a terse response. 2.14e+06. In the year 2009, what is the difference between the Aid flow from UN agencies (US$) of Thailand and Aid flow from UN agencies (US$) of Yemen, Rep.?
Provide a succinct answer. -2.86e+06. What is the ratio of the Aid flow from UN agencies (US$) in Algeria in 2003 to that in 2004?
Provide a succinct answer. 0.91. What is the ratio of the Aid flow from UN agencies (US$) in Tajikistan in 2003 to that in 2004?
Offer a very short reply. 0.54. What is the ratio of the Aid flow from UN agencies (US$) of Thailand in 2003 to that in 2004?
Provide a short and direct response. 0.34. What is the ratio of the Aid flow from UN agencies (US$) in Yemen, Rep. in 2003 to that in 2004?
Your answer should be very brief. 0.84. What is the ratio of the Aid flow from UN agencies (US$) of Algeria in 2003 to that in 2005?
Offer a very short reply. 0.98. What is the ratio of the Aid flow from UN agencies (US$) in Tajikistan in 2003 to that in 2005?
Make the answer very short. 0.52. What is the ratio of the Aid flow from UN agencies (US$) in Thailand in 2003 to that in 2005?
Provide a short and direct response. 0.22. What is the ratio of the Aid flow from UN agencies (US$) in Yemen, Rep. in 2003 to that in 2005?
Provide a succinct answer. 0.79. What is the ratio of the Aid flow from UN agencies (US$) in Algeria in 2003 to that in 2006?
Your answer should be very brief. 0.76. What is the ratio of the Aid flow from UN agencies (US$) in Tajikistan in 2003 to that in 2006?
Give a very brief answer. 0.52. What is the ratio of the Aid flow from UN agencies (US$) of Thailand in 2003 to that in 2006?
Keep it short and to the point. 0.26. What is the ratio of the Aid flow from UN agencies (US$) of Yemen, Rep. in 2003 to that in 2006?
Keep it short and to the point. 1.11. What is the ratio of the Aid flow from UN agencies (US$) of Algeria in 2003 to that in 2007?
Provide a succinct answer. 0.92. What is the ratio of the Aid flow from UN agencies (US$) in Tajikistan in 2003 to that in 2007?
Provide a short and direct response. 0.63. What is the ratio of the Aid flow from UN agencies (US$) of Thailand in 2003 to that in 2007?
Your response must be concise. 0.44. What is the ratio of the Aid flow from UN agencies (US$) in Yemen, Rep. in 2003 to that in 2007?
Provide a succinct answer. 1.15. What is the ratio of the Aid flow from UN agencies (US$) of Algeria in 2003 to that in 2008?
Your answer should be compact. 1.21. What is the ratio of the Aid flow from UN agencies (US$) of Tajikistan in 2003 to that in 2008?
Make the answer very short. 0.47. What is the ratio of the Aid flow from UN agencies (US$) of Thailand in 2003 to that in 2008?
Offer a very short reply. 0.52. What is the ratio of the Aid flow from UN agencies (US$) in Yemen, Rep. in 2003 to that in 2008?
Provide a short and direct response. 1.73. What is the ratio of the Aid flow from UN agencies (US$) of Algeria in 2003 to that in 2009?
Provide a succinct answer. 1.67. What is the ratio of the Aid flow from UN agencies (US$) of Tajikistan in 2003 to that in 2009?
Provide a succinct answer. 0.3. What is the ratio of the Aid flow from UN agencies (US$) in Thailand in 2003 to that in 2009?
Your answer should be compact. 0.35. What is the ratio of the Aid flow from UN agencies (US$) of Yemen, Rep. in 2003 to that in 2009?
Offer a very short reply. 1.1. What is the ratio of the Aid flow from UN agencies (US$) in Algeria in 2004 to that in 2005?
Keep it short and to the point. 1.08. What is the ratio of the Aid flow from UN agencies (US$) in Tajikistan in 2004 to that in 2005?
Your answer should be compact. 0.96. What is the ratio of the Aid flow from UN agencies (US$) of Thailand in 2004 to that in 2005?
Give a very brief answer. 0.65. What is the ratio of the Aid flow from UN agencies (US$) in Yemen, Rep. in 2004 to that in 2005?
Keep it short and to the point. 0.95. What is the ratio of the Aid flow from UN agencies (US$) in Algeria in 2004 to that in 2006?
Provide a short and direct response. 0.84. What is the ratio of the Aid flow from UN agencies (US$) of Tajikistan in 2004 to that in 2006?
Make the answer very short. 0.96. What is the ratio of the Aid flow from UN agencies (US$) of Thailand in 2004 to that in 2006?
Give a very brief answer. 0.78. What is the ratio of the Aid flow from UN agencies (US$) of Yemen, Rep. in 2004 to that in 2006?
Make the answer very short. 1.32. What is the ratio of the Aid flow from UN agencies (US$) of Tajikistan in 2004 to that in 2007?
Ensure brevity in your answer.  1.15. What is the ratio of the Aid flow from UN agencies (US$) of Thailand in 2004 to that in 2007?
Provide a succinct answer. 1.31. What is the ratio of the Aid flow from UN agencies (US$) of Yemen, Rep. in 2004 to that in 2007?
Your response must be concise. 1.37. What is the ratio of the Aid flow from UN agencies (US$) of Algeria in 2004 to that in 2008?
Keep it short and to the point. 1.34. What is the ratio of the Aid flow from UN agencies (US$) in Tajikistan in 2004 to that in 2008?
Your answer should be compact. 0.86. What is the ratio of the Aid flow from UN agencies (US$) in Thailand in 2004 to that in 2008?
Your response must be concise. 1.54. What is the ratio of the Aid flow from UN agencies (US$) in Yemen, Rep. in 2004 to that in 2008?
Offer a terse response. 2.06. What is the ratio of the Aid flow from UN agencies (US$) in Algeria in 2004 to that in 2009?
Make the answer very short. 1.84. What is the ratio of the Aid flow from UN agencies (US$) of Tajikistan in 2004 to that in 2009?
Your response must be concise. 0.56. What is the ratio of the Aid flow from UN agencies (US$) of Thailand in 2004 to that in 2009?
Your answer should be very brief. 1.04. What is the ratio of the Aid flow from UN agencies (US$) in Yemen, Rep. in 2004 to that in 2009?
Make the answer very short. 1.31. What is the ratio of the Aid flow from UN agencies (US$) in Algeria in 2005 to that in 2006?
Provide a short and direct response. 0.78. What is the ratio of the Aid flow from UN agencies (US$) in Tajikistan in 2005 to that in 2006?
Keep it short and to the point. 1.01. What is the ratio of the Aid flow from UN agencies (US$) of Thailand in 2005 to that in 2006?
Make the answer very short. 1.19. What is the ratio of the Aid flow from UN agencies (US$) in Yemen, Rep. in 2005 to that in 2006?
Provide a short and direct response. 1.4. What is the ratio of the Aid flow from UN agencies (US$) in Algeria in 2005 to that in 2007?
Make the answer very short. 0.94. What is the ratio of the Aid flow from UN agencies (US$) in Tajikistan in 2005 to that in 2007?
Your response must be concise. 1.2. What is the ratio of the Aid flow from UN agencies (US$) of Thailand in 2005 to that in 2007?
Offer a very short reply. 2.01. What is the ratio of the Aid flow from UN agencies (US$) in Yemen, Rep. in 2005 to that in 2007?
Give a very brief answer. 1.45. What is the ratio of the Aid flow from UN agencies (US$) of Algeria in 2005 to that in 2008?
Make the answer very short. 1.24. What is the ratio of the Aid flow from UN agencies (US$) of Tajikistan in 2005 to that in 2008?
Provide a short and direct response. 0.9. What is the ratio of the Aid flow from UN agencies (US$) in Thailand in 2005 to that in 2008?
Provide a succinct answer. 2.36. What is the ratio of the Aid flow from UN agencies (US$) in Yemen, Rep. in 2005 to that in 2008?
Give a very brief answer. 2.18. What is the ratio of the Aid flow from UN agencies (US$) of Algeria in 2005 to that in 2009?
Ensure brevity in your answer.  1.71. What is the ratio of the Aid flow from UN agencies (US$) of Tajikistan in 2005 to that in 2009?
Give a very brief answer. 0.58. What is the ratio of the Aid flow from UN agencies (US$) in Thailand in 2005 to that in 2009?
Offer a terse response. 1.6. What is the ratio of the Aid flow from UN agencies (US$) of Yemen, Rep. in 2005 to that in 2009?
Your answer should be compact. 1.38. What is the ratio of the Aid flow from UN agencies (US$) in Algeria in 2006 to that in 2007?
Ensure brevity in your answer.  1.21. What is the ratio of the Aid flow from UN agencies (US$) in Tajikistan in 2006 to that in 2007?
Your answer should be compact. 1.2. What is the ratio of the Aid flow from UN agencies (US$) in Thailand in 2006 to that in 2007?
Offer a terse response. 1.69. What is the ratio of the Aid flow from UN agencies (US$) of Yemen, Rep. in 2006 to that in 2007?
Make the answer very short. 1.03. What is the ratio of the Aid flow from UN agencies (US$) of Algeria in 2006 to that in 2008?
Keep it short and to the point. 1.59. What is the ratio of the Aid flow from UN agencies (US$) of Tajikistan in 2006 to that in 2008?
Provide a succinct answer. 0.9. What is the ratio of the Aid flow from UN agencies (US$) of Thailand in 2006 to that in 2008?
Give a very brief answer. 1.99. What is the ratio of the Aid flow from UN agencies (US$) of Yemen, Rep. in 2006 to that in 2008?
Give a very brief answer. 1.56. What is the ratio of the Aid flow from UN agencies (US$) of Algeria in 2006 to that in 2009?
Ensure brevity in your answer.  2.19. What is the ratio of the Aid flow from UN agencies (US$) in Tajikistan in 2006 to that in 2009?
Give a very brief answer. 0.58. What is the ratio of the Aid flow from UN agencies (US$) of Thailand in 2006 to that in 2009?
Offer a terse response. 1.35. What is the ratio of the Aid flow from UN agencies (US$) of Yemen, Rep. in 2006 to that in 2009?
Your response must be concise. 0.99. What is the ratio of the Aid flow from UN agencies (US$) in Algeria in 2007 to that in 2008?
Provide a short and direct response. 1.31. What is the ratio of the Aid flow from UN agencies (US$) in Tajikistan in 2007 to that in 2008?
Ensure brevity in your answer.  0.75. What is the ratio of the Aid flow from UN agencies (US$) of Thailand in 2007 to that in 2008?
Your response must be concise. 1.17. What is the ratio of the Aid flow from UN agencies (US$) in Yemen, Rep. in 2007 to that in 2008?
Make the answer very short. 1.51. What is the ratio of the Aid flow from UN agencies (US$) in Algeria in 2007 to that in 2009?
Offer a very short reply. 1.81. What is the ratio of the Aid flow from UN agencies (US$) of Tajikistan in 2007 to that in 2009?
Offer a terse response. 0.48. What is the ratio of the Aid flow from UN agencies (US$) of Thailand in 2007 to that in 2009?
Ensure brevity in your answer.  0.79. What is the ratio of the Aid flow from UN agencies (US$) of Yemen, Rep. in 2007 to that in 2009?
Make the answer very short. 0.95. What is the ratio of the Aid flow from UN agencies (US$) in Algeria in 2008 to that in 2009?
Your answer should be very brief. 1.38. What is the ratio of the Aid flow from UN agencies (US$) of Tajikistan in 2008 to that in 2009?
Offer a terse response. 0.65. What is the ratio of the Aid flow from UN agencies (US$) in Thailand in 2008 to that in 2009?
Keep it short and to the point. 0.68. What is the ratio of the Aid flow from UN agencies (US$) of Yemen, Rep. in 2008 to that in 2009?
Your response must be concise. 0.63. What is the difference between the highest and the second highest Aid flow from UN agencies (US$) in Algeria?
Your response must be concise. 2.00e+05. What is the difference between the highest and the second highest Aid flow from UN agencies (US$) in Tajikistan?
Your response must be concise. 2.24e+06. What is the difference between the highest and the second highest Aid flow from UN agencies (US$) in Yemen, Rep.?
Your answer should be compact. 3.20e+05. What is the difference between the highest and the lowest Aid flow from UN agencies (US$) in Algeria?
Provide a succinct answer. 6.90e+05. What is the difference between the highest and the lowest Aid flow from UN agencies (US$) of Tajikistan?
Your answer should be compact. 4.43e+06. What is the difference between the highest and the lowest Aid flow from UN agencies (US$) in Thailand?
Your response must be concise. 1.69e+06. What is the difference between the highest and the lowest Aid flow from UN agencies (US$) in Yemen, Rep.?
Your response must be concise. 3.16e+06. 